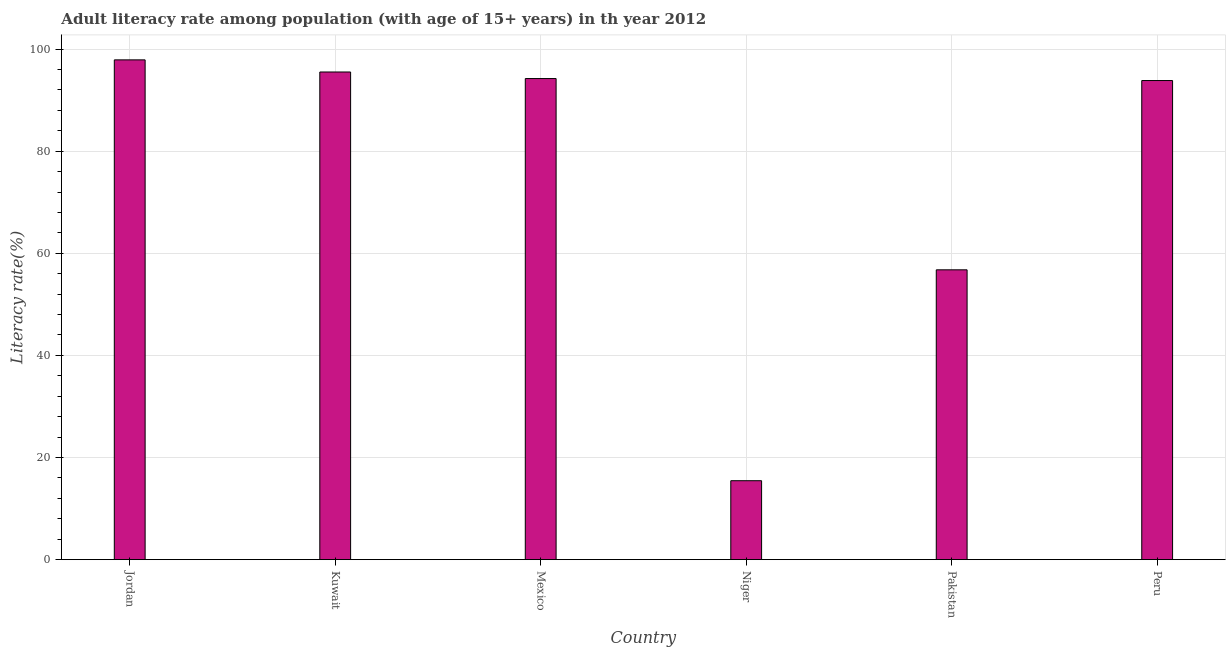Does the graph contain any zero values?
Make the answer very short. No. What is the title of the graph?
Offer a very short reply. Adult literacy rate among population (with age of 15+ years) in th year 2012. What is the label or title of the X-axis?
Give a very brief answer. Country. What is the label or title of the Y-axis?
Your answer should be compact. Literacy rate(%). What is the adult literacy rate in Kuwait?
Make the answer very short. 95.51. Across all countries, what is the maximum adult literacy rate?
Give a very brief answer. 97.89. Across all countries, what is the minimum adult literacy rate?
Provide a succinct answer. 15.46. In which country was the adult literacy rate maximum?
Provide a short and direct response. Jordan. In which country was the adult literacy rate minimum?
Provide a succinct answer. Niger. What is the sum of the adult literacy rate?
Your response must be concise. 453.69. What is the difference between the adult literacy rate in Mexico and Niger?
Give a very brief answer. 78.77. What is the average adult literacy rate per country?
Your answer should be very brief. 75.62. What is the median adult literacy rate?
Keep it short and to the point. 94.04. In how many countries, is the adult literacy rate greater than 96 %?
Your answer should be very brief. 1. What is the ratio of the adult literacy rate in Mexico to that in Niger?
Make the answer very short. 6.1. Is the difference between the adult literacy rate in Kuwait and Pakistan greater than the difference between any two countries?
Offer a terse response. No. What is the difference between the highest and the second highest adult literacy rate?
Your response must be concise. 2.38. What is the difference between the highest and the lowest adult literacy rate?
Your response must be concise. 82.43. In how many countries, is the adult literacy rate greater than the average adult literacy rate taken over all countries?
Your response must be concise. 4. Are the values on the major ticks of Y-axis written in scientific E-notation?
Provide a succinct answer. No. What is the Literacy rate(%) in Jordan?
Your answer should be compact. 97.89. What is the Literacy rate(%) of Kuwait?
Your answer should be compact. 95.51. What is the Literacy rate(%) in Mexico?
Offer a very short reply. 94.23. What is the Literacy rate(%) of Niger?
Your answer should be very brief. 15.46. What is the Literacy rate(%) of Pakistan?
Provide a short and direct response. 56.76. What is the Literacy rate(%) of Peru?
Provide a succinct answer. 93.84. What is the difference between the Literacy rate(%) in Jordan and Kuwait?
Keep it short and to the point. 2.38. What is the difference between the Literacy rate(%) in Jordan and Mexico?
Give a very brief answer. 3.66. What is the difference between the Literacy rate(%) in Jordan and Niger?
Give a very brief answer. 82.43. What is the difference between the Literacy rate(%) in Jordan and Pakistan?
Offer a terse response. 41.13. What is the difference between the Literacy rate(%) in Jordan and Peru?
Ensure brevity in your answer.  4.05. What is the difference between the Literacy rate(%) in Kuwait and Mexico?
Provide a short and direct response. 1.28. What is the difference between the Literacy rate(%) in Kuwait and Niger?
Your answer should be compact. 80.06. What is the difference between the Literacy rate(%) in Kuwait and Pakistan?
Offer a terse response. 38.75. What is the difference between the Literacy rate(%) in Kuwait and Peru?
Make the answer very short. 1.67. What is the difference between the Literacy rate(%) in Mexico and Niger?
Make the answer very short. 78.77. What is the difference between the Literacy rate(%) in Mexico and Pakistan?
Give a very brief answer. 37.46. What is the difference between the Literacy rate(%) in Mexico and Peru?
Ensure brevity in your answer.  0.39. What is the difference between the Literacy rate(%) in Niger and Pakistan?
Offer a terse response. -41.31. What is the difference between the Literacy rate(%) in Niger and Peru?
Make the answer very short. -78.39. What is the difference between the Literacy rate(%) in Pakistan and Peru?
Keep it short and to the point. -37.08. What is the ratio of the Literacy rate(%) in Jordan to that in Mexico?
Provide a short and direct response. 1.04. What is the ratio of the Literacy rate(%) in Jordan to that in Niger?
Your answer should be very brief. 6.33. What is the ratio of the Literacy rate(%) in Jordan to that in Pakistan?
Keep it short and to the point. 1.73. What is the ratio of the Literacy rate(%) in Jordan to that in Peru?
Make the answer very short. 1.04. What is the ratio of the Literacy rate(%) in Kuwait to that in Mexico?
Provide a succinct answer. 1.01. What is the ratio of the Literacy rate(%) in Kuwait to that in Niger?
Make the answer very short. 6.18. What is the ratio of the Literacy rate(%) in Kuwait to that in Pakistan?
Your answer should be very brief. 1.68. What is the ratio of the Literacy rate(%) in Kuwait to that in Peru?
Keep it short and to the point. 1.02. What is the ratio of the Literacy rate(%) in Mexico to that in Niger?
Make the answer very short. 6.1. What is the ratio of the Literacy rate(%) in Mexico to that in Pakistan?
Your answer should be compact. 1.66. What is the ratio of the Literacy rate(%) in Niger to that in Pakistan?
Give a very brief answer. 0.27. What is the ratio of the Literacy rate(%) in Niger to that in Peru?
Keep it short and to the point. 0.17. What is the ratio of the Literacy rate(%) in Pakistan to that in Peru?
Keep it short and to the point. 0.6. 